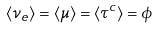Convert formula to latex. <formula><loc_0><loc_0><loc_500><loc_500>\langle \nu _ { e } \rangle = \langle \mu \rangle = \langle \tau ^ { c } \rangle = \phi</formula> 